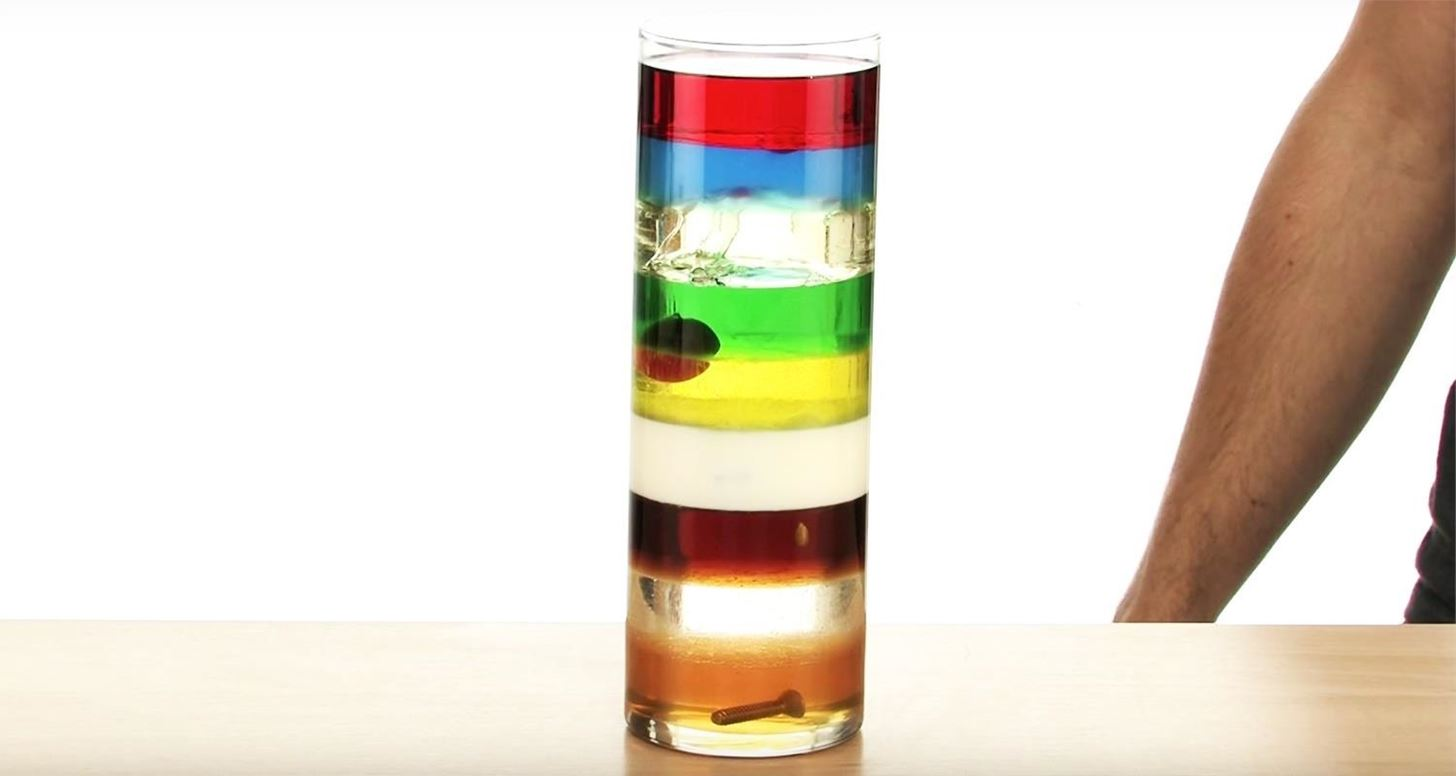Given the careful layering of the liquids, what could be the reason or principle behind the ability of the screw and cherry to float within the green layer rather than sinking to the bottom or floating to the top? The careful layering of the liquids demonstrates a principle based on density variations among the different fluids. Each liquid layer has a unique density that prevents them from mixing and keeps them distinct. The screw and cherry float within the green layer, which suggests that they have similar densities to the green liquid. Consequently, the green liquid's density is more than that of the cherry and screw but less than the yellow liquid above it. Thus, the screw and cherry remain suspended and don't sink or rise. This phenomenon arises from the principle of buoyancy, which dictates that an object will float in a liquid if its density is less than the liquid's density. 